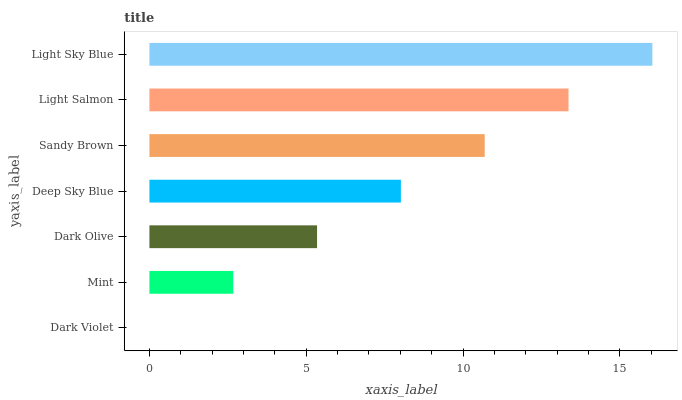Is Dark Violet the minimum?
Answer yes or no. Yes. Is Light Sky Blue the maximum?
Answer yes or no. Yes. Is Mint the minimum?
Answer yes or no. No. Is Mint the maximum?
Answer yes or no. No. Is Mint greater than Dark Violet?
Answer yes or no. Yes. Is Dark Violet less than Mint?
Answer yes or no. Yes. Is Dark Violet greater than Mint?
Answer yes or no. No. Is Mint less than Dark Violet?
Answer yes or no. No. Is Deep Sky Blue the high median?
Answer yes or no. Yes. Is Deep Sky Blue the low median?
Answer yes or no. Yes. Is Light Salmon the high median?
Answer yes or no. No. Is Sandy Brown the low median?
Answer yes or no. No. 